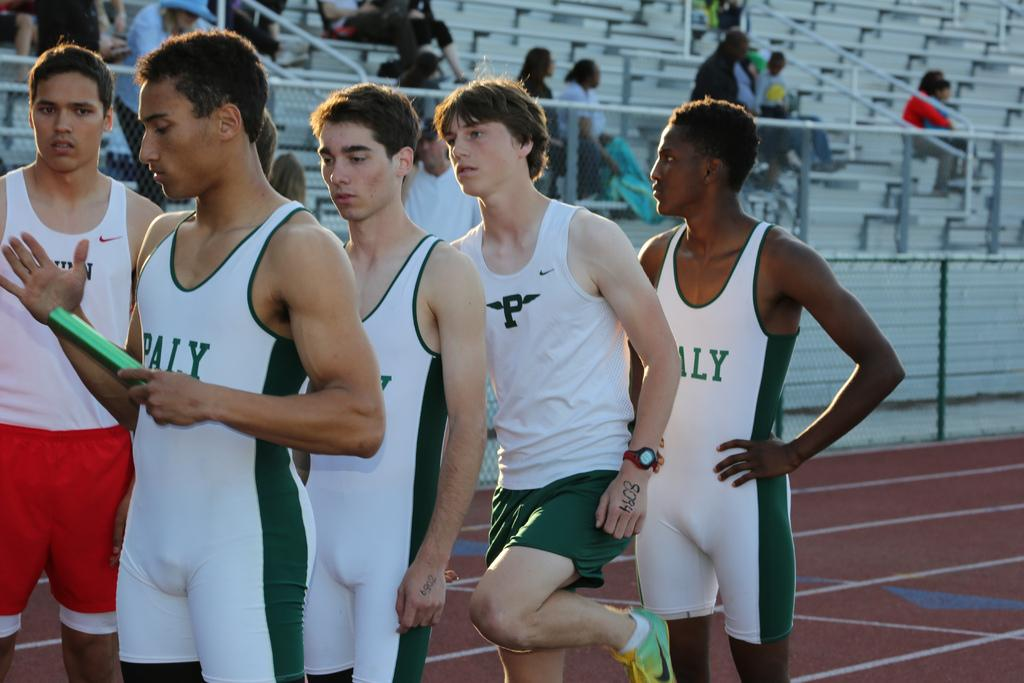<image>
Give a short and clear explanation of the subsequent image. 4 runners wearing PALY uniforms are lined up for a relay race. 